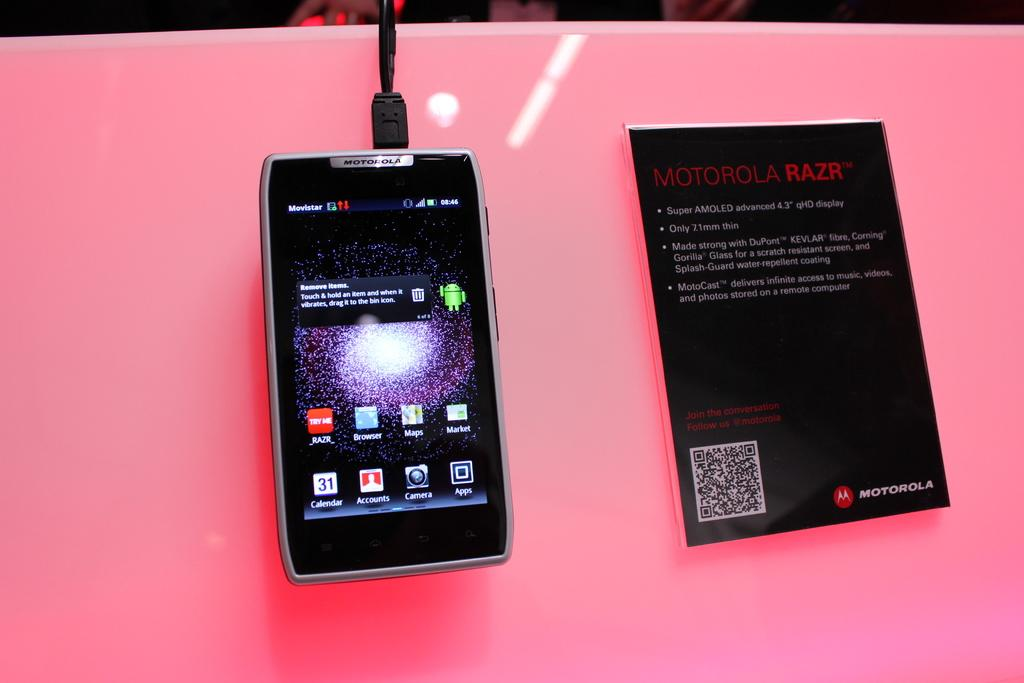<image>
Share a concise interpretation of the image provided. A cellphone is next to packaging that says Motorola Razr on it. 